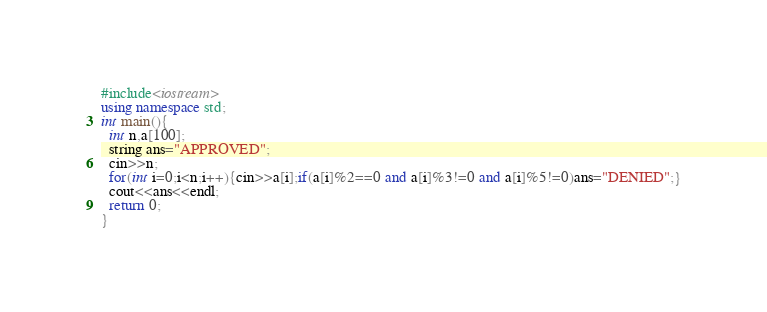Convert code to text. <code><loc_0><loc_0><loc_500><loc_500><_C++_>#include<iostream>
using namespace std;
int main(){
  int n,a[100];
  string ans="APPROVED";
  cin>>n;
  for(int i=0;i<n;i++){cin>>a[i];if(a[i]%2==0 and a[i]%3!=0 and a[i]%5!=0)ans="DENIED";}
  cout<<ans<<endl;
  return 0;
}</code> 